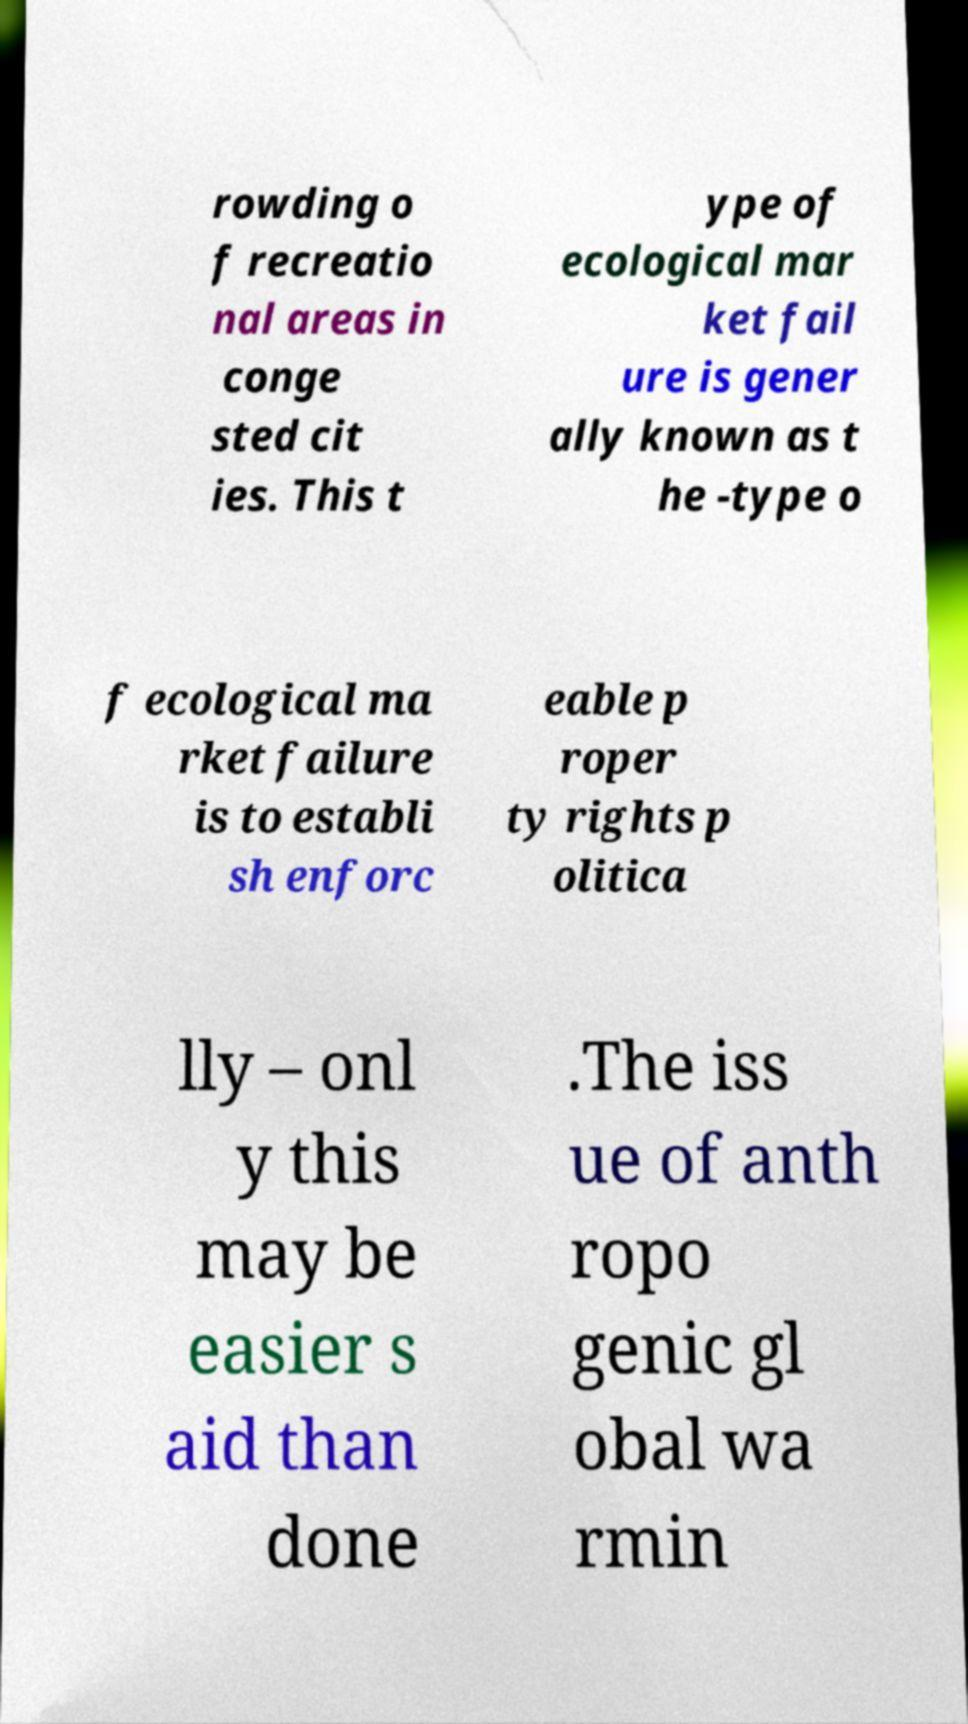What messages or text are displayed in this image? I need them in a readable, typed format. rowding o f recreatio nal areas in conge sted cit ies. This t ype of ecological mar ket fail ure is gener ally known as t he -type o f ecological ma rket failure is to establi sh enforc eable p roper ty rights p olitica lly – onl y this may be easier s aid than done .The iss ue of anth ropo genic gl obal wa rmin 